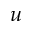Convert formula to latex. <formula><loc_0><loc_0><loc_500><loc_500>u</formula> 